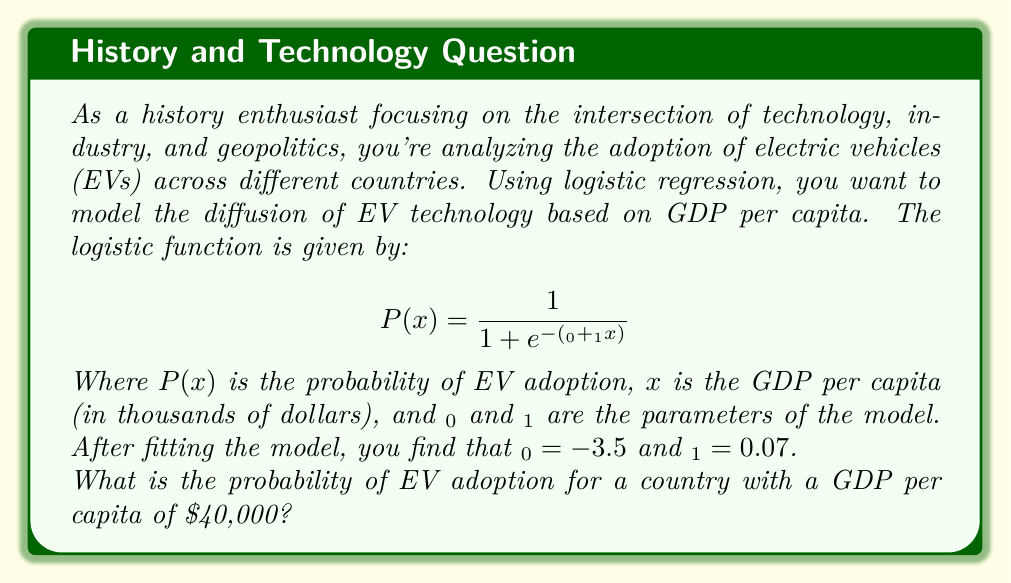Solve this math problem. To solve this problem, we need to follow these steps:

1. Identify the given information:
   - Logistic function: $P(x) = \frac{1}{1 + e^{-(β_0 + β_1x)}}$
   - $β_0 = -3.5$
   - $β_1 = 0.07$
   - $x = 40$ (GDP per capita in thousands of dollars)

2. Substitute the values into the logistic function:
   $P(40) = \frac{1}{1 + e^{-(-3.5 + 0.07 * 40)}}$

3. Simplify the expression inside the exponential:
   $P(40) = \frac{1}{1 + e^{-(-3.5 + 2.8)}}$
   $P(40) = \frac{1}{1 + e^{-(0.7)}}$

4. Calculate the value of $e^{-0.7}$:
   $e^{-0.7} \approx 0.4966$

5. Substitute this value back into the equation:
   $P(40) = \frac{1}{1 + 0.4966}$

6. Perform the final calculation:
   $P(40) = \frac{1}{1.4966} \approx 0.6682$

Therefore, the probability of EV adoption for a country with a GDP per capita of $40,000 is approximately 0.6682 or 66.82%.

This result shows how logistic regression can be used to model the diffusion of new technologies (in this case, electric vehicles) across different countries based on economic factors. The model suggests that countries with higher GDP per capita are more likely to adopt EV technology, which aligns with historical patterns of technological diffusion.
Answer: 0.6682 or 66.82% 